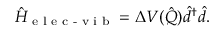<formula> <loc_0><loc_0><loc_500><loc_500>\hat { H } _ { e l e c - v i b } = \Delta V ( \hat { Q } ) \hat { d } ^ { \dagger } \hat { d } .</formula> 